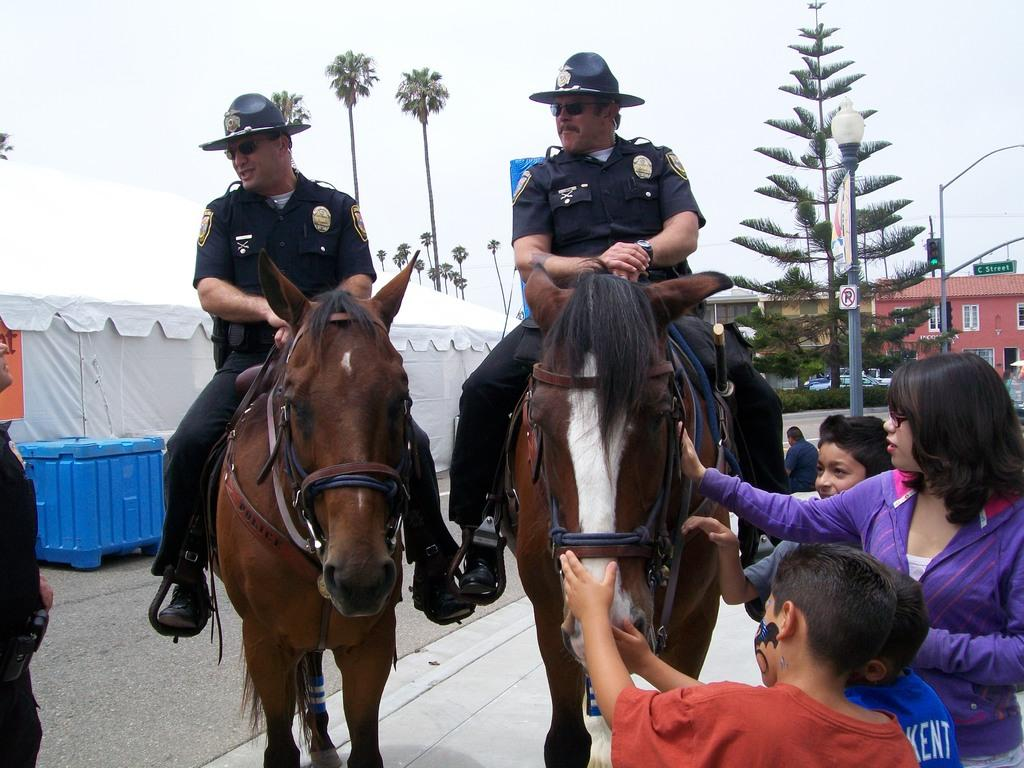What is the main subject of the image? There are persons sitting on a horse in the image. Can you describe the people in the image? There are people visible in the image. What can be seen in the background of the image? There are buildings, sheds, and trees in the background of the image. What type of sound can be heard coming from the guitar in the image? There is no guitar present in the image, so it is not possible to determine what sound might be heard. 